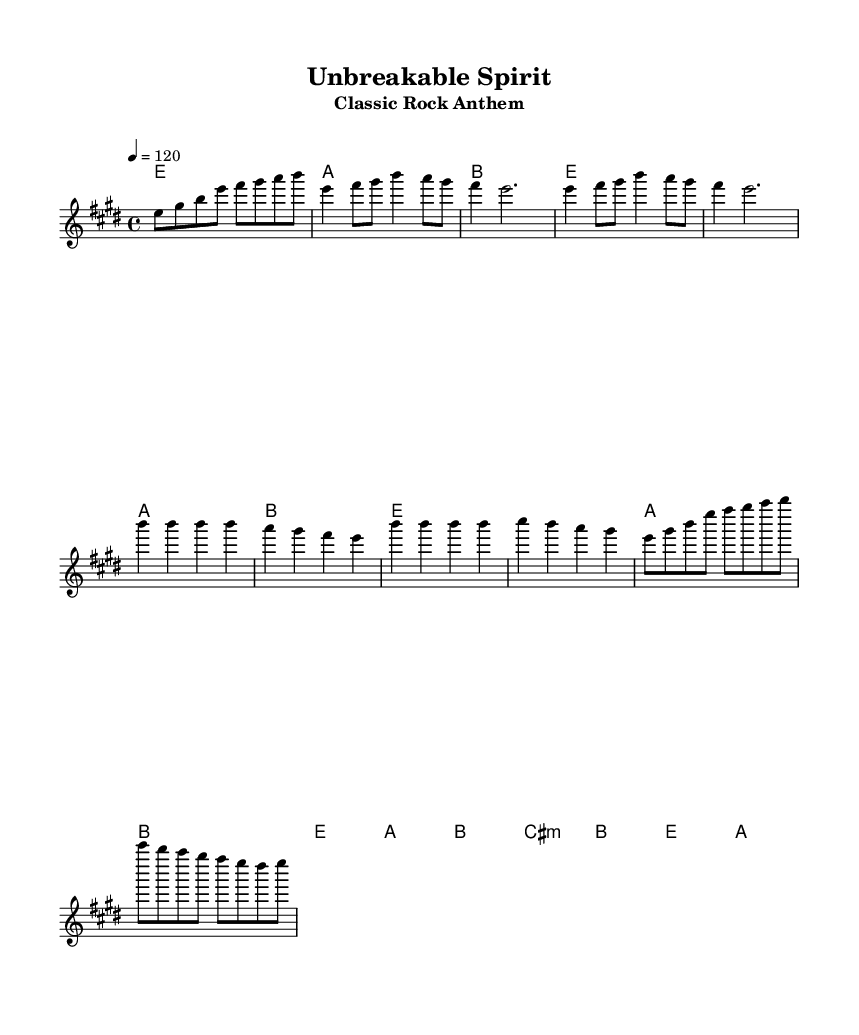What is the key signature of this music? The key signature is E major, which contains four sharps (F sharp, C sharp, G sharp, D sharp). This can be inferred from the key indication at the beginning of the sheet music.
Answer: E major What is the time signature of this music? The time signature is 4/4, indicated by the notation at the beginning of the score. This means there are four beats in each measure and a quarter note gets one beat.
Answer: 4/4 What is the tempo marked in this music? The tempo marking is 120 beats per minute, shown at the beginning of the score as "4 = 120". This means one quarter note gets 120 beats per minute.
Answer: 120 How many measures are in the verse section? The verse section contains four measures, indicated by the grouping of notes in the melody part under the verse label. Each measure has a clear set of notes, showing continuity in that section.
Answer: 4 What is the first note in the chorus? The first note in the chorus is B, which is indicated as the starting note for the first measure under the chorus section. This establishes the melody line for that part of the song.
Answer: B What chord is played during the first measure? The chord played during the first measure is E major, confirmed by the chord indicated above the staff during the intro and repeated in the verse section.
Answer: E Which section follows the chorus in the music? The section that follows the chorus is the solo section, which is clearly labeled and contains a distinct melody that sets it apart from the verses and chorus.
Answer: Solo 